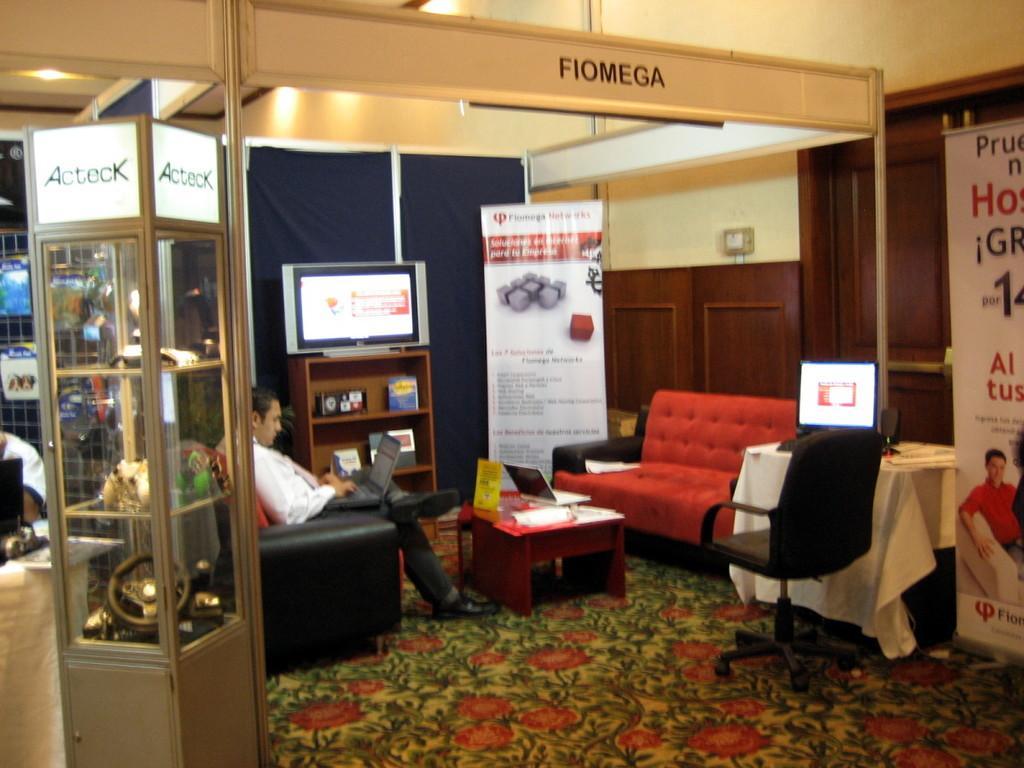In one or two sentences, can you explain what this image depicts? There is a person sitting on the chair and working on the laptop. In this room there are hoardings,TV,cupboards,table,chair and wall. 